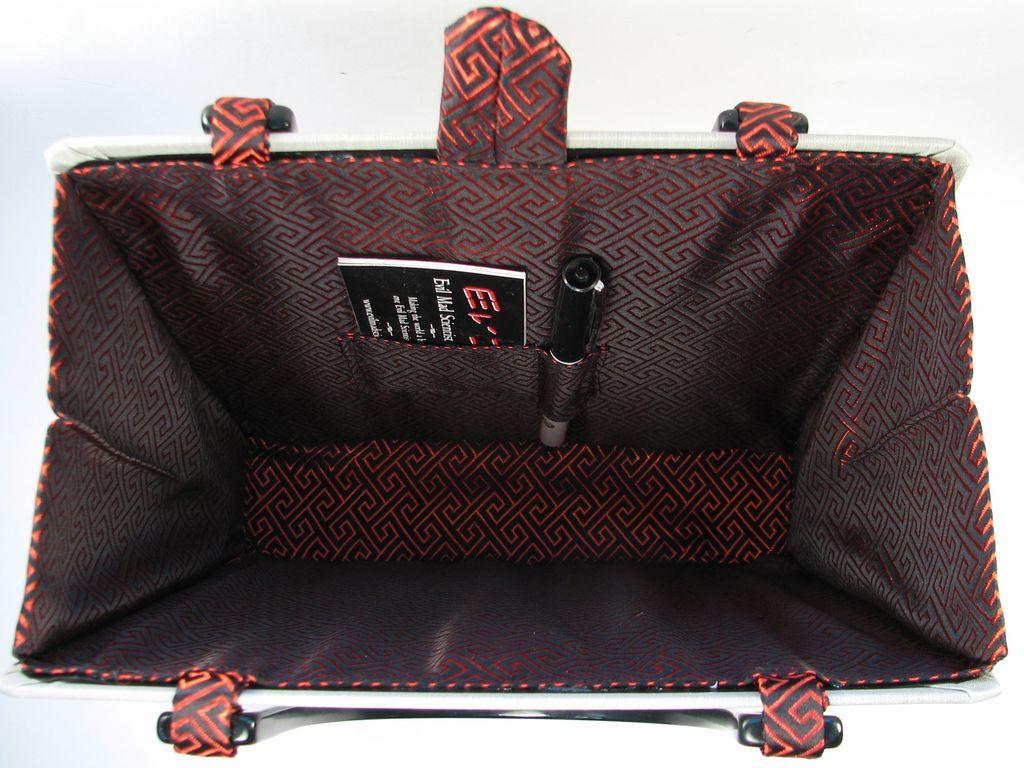Could you give a brief overview of what you see in this image? In the image there is a bag. Inside a bag we can see a book and a pen and we can also black color which is attached to the bag. 